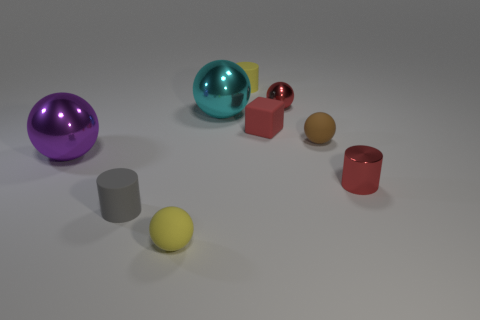What shape is the gray rubber thing that is the same size as the red rubber object? The gray rubber object that matches the red object in size is a sphere. 